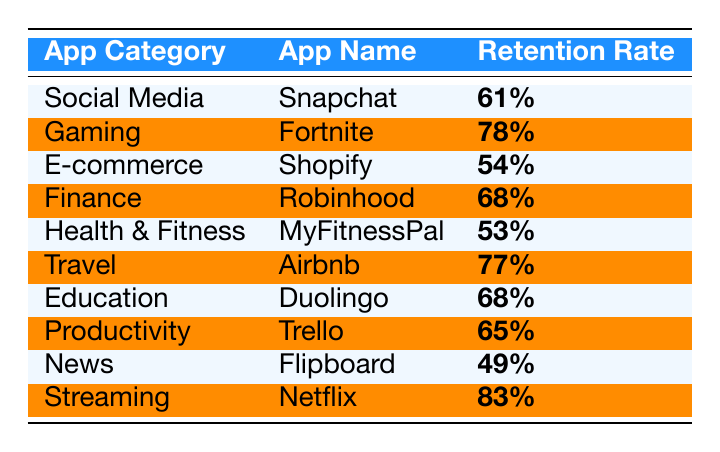What is the retention rate for Snapchat? The table shows that under the "Social Media" app category, the retention rate for Snapchat is highlighted as 61%.
Answer: 61% Which app has the highest retention rate? Looking at the table, Netflix is listed under the "Streaming" category with a retention rate of 83%, which is the highest among all listed apps.
Answer: 83% What is the average retention rate of all apps listed in the table? To calculate the average, first sum all the retention rates: 61 + 78 + 54 + 68 + 53 + 77 + 68 + 65 + 49 + 83 = 615. Then divide this sum by the number of apps (10): 615 / 10 = 61.5%.
Answer: 61.5% Is the retention rate of Shopify higher than that of MyFitnessPal? The retention rate for Shopify is 54%, while for MyFitnessPal it is 53%, so Shopify's retention rate is higher.
Answer: Yes Which app categories have retention rates above 70%? From the table, the apps with retention rates above 70% are Fortnite (78%), Airbnb (77%), and Netflix (83%).
Answer: Gaming, Travel, Streaming What is the difference in retention rates between Netflix and Flipboard? Netflix has a retention rate of 83% and Flipboard has a rate of 49%. The difference is calculated as 83 - 49 = 34%.
Answer: 34% Are there any app categories where both apps listed have the same retention rate? The table shows the retention rate for Robinhood and Duolingo as both being 68%, fulfilling this condition.
Answer: Yes What is the retention rate for the Education category? The table indicates that the retention rate for the Education category, associated with Duolingo, is 68%.
Answer: 68% Which app category has the lowest retention rate, and what is that rate? Reviewing the table, the News app category, represented by Flipboard, has the lowest retention rate at 49%.
Answer: News, 49% What is the combined retention rate of the Health & Fitness and E-commerce categories? The retention rate for Health & Fitness (MyFitnessPal) is 53%, and for E-commerce (Shopify) it is 54%. Adding these two rates gives 53 + 54 = 107%.
Answer: 107% 